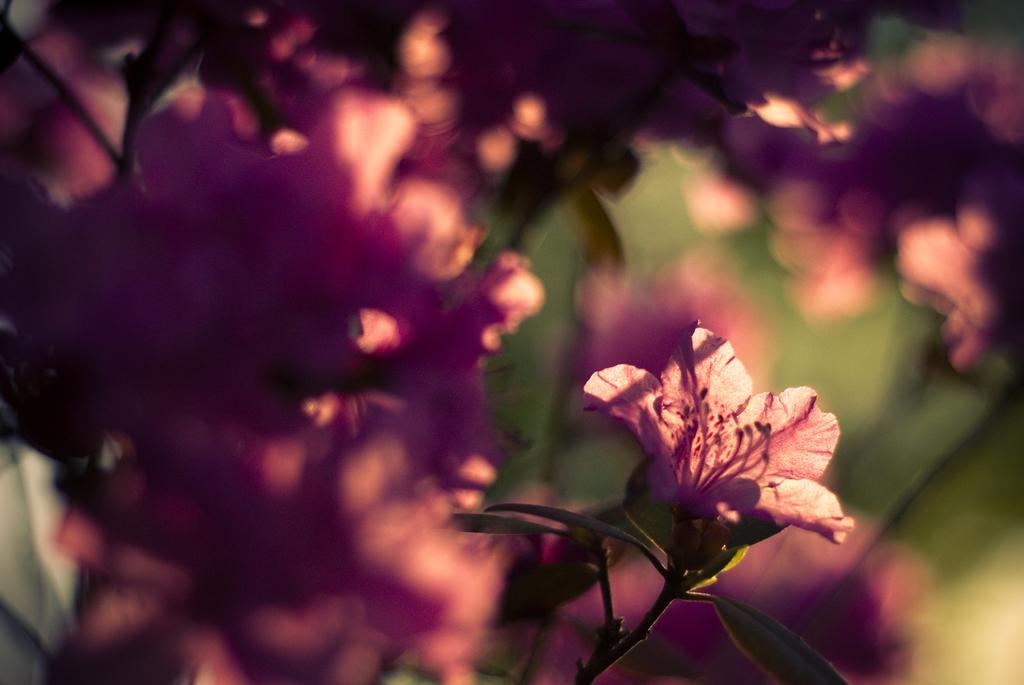Can you describe this image briefly? In the picture I can see the pink color flowers of a plant and the surroundings of the image are blurred. 